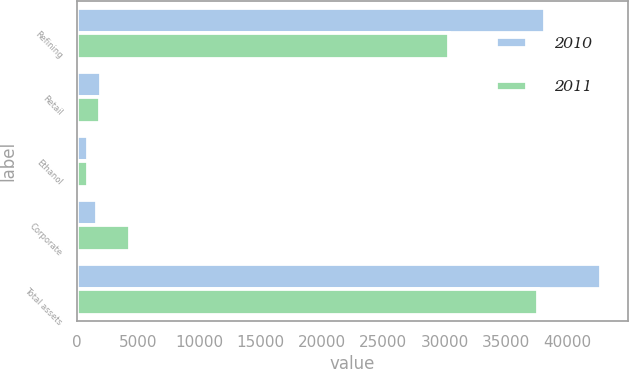Convert chart. <chart><loc_0><loc_0><loc_500><loc_500><stacked_bar_chart><ecel><fcel>Refining<fcel>Retail<fcel>Ethanol<fcel>Corporate<fcel>Total assets<nl><fcel>2010<fcel>38164<fcel>1999<fcel>943<fcel>1677<fcel>42783<nl><fcel>2011<fcel>30363<fcel>1925<fcel>953<fcel>4380<fcel>37621<nl></chart> 